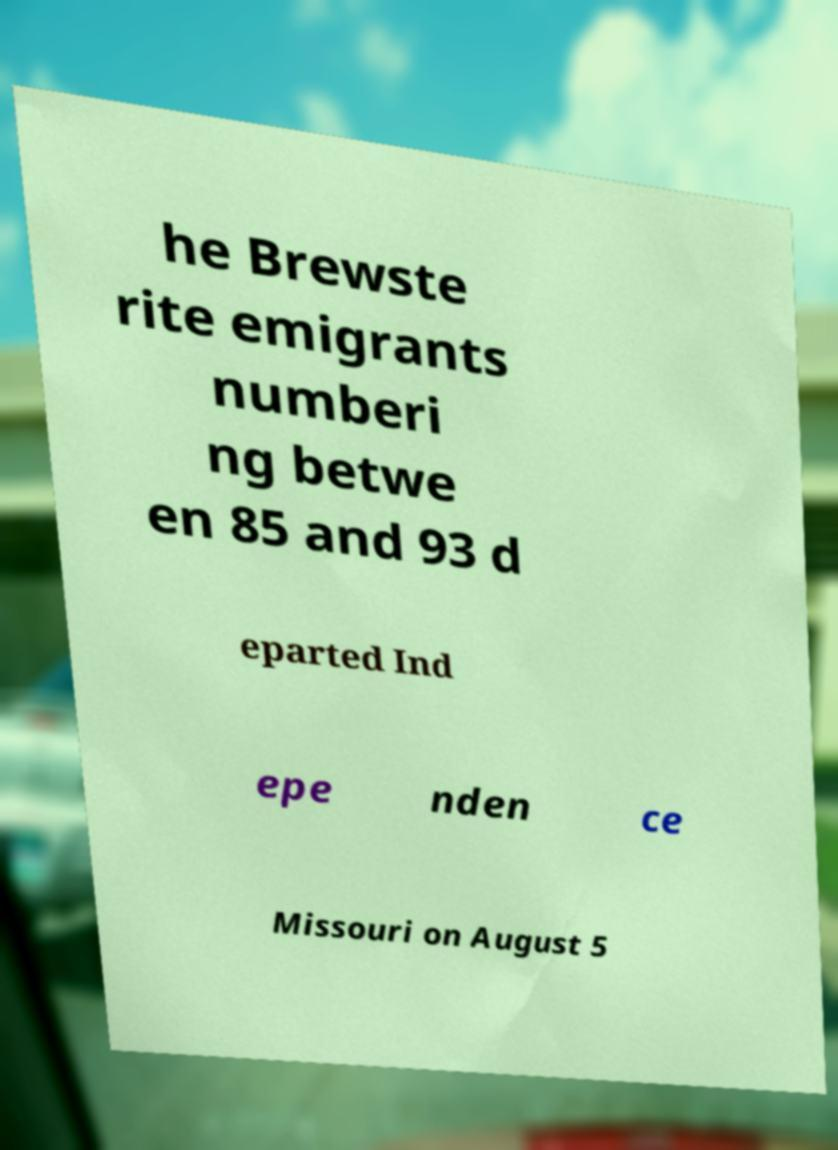Could you assist in decoding the text presented in this image and type it out clearly? he Brewste rite emigrants numberi ng betwe en 85 and 93 d eparted Ind epe nden ce Missouri on August 5 